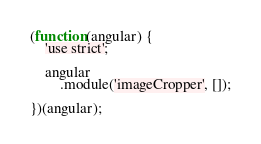Convert code to text. <code><loc_0><loc_0><loc_500><loc_500><_JavaScript_>(function(angular) {
    'use strict';

    angular
        .module('imageCropper', []);

})(angular);
</code> 